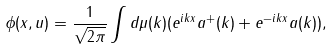<formula> <loc_0><loc_0><loc_500><loc_500>\phi ( x , u ) = \frac { 1 } { \sqrt { 2 \pi } } \int d \mu ( k ) ( e ^ { i k x } a ^ { + } ( k ) + e ^ { - i k x } a ( k ) ) ,</formula> 